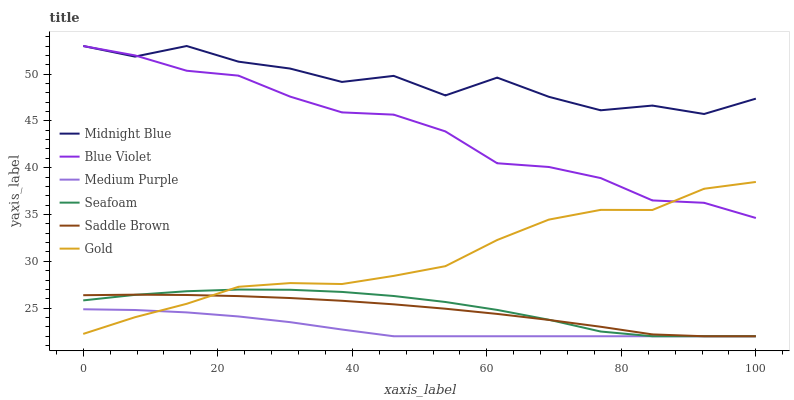Does Medium Purple have the minimum area under the curve?
Answer yes or no. Yes. Does Midnight Blue have the maximum area under the curve?
Answer yes or no. Yes. Does Gold have the minimum area under the curve?
Answer yes or no. No. Does Gold have the maximum area under the curve?
Answer yes or no. No. Is Medium Purple the smoothest?
Answer yes or no. Yes. Is Midnight Blue the roughest?
Answer yes or no. Yes. Is Gold the smoothest?
Answer yes or no. No. Is Gold the roughest?
Answer yes or no. No. Does Seafoam have the lowest value?
Answer yes or no. Yes. Does Gold have the lowest value?
Answer yes or no. No. Does Blue Violet have the highest value?
Answer yes or no. Yes. Does Gold have the highest value?
Answer yes or no. No. Is Seafoam less than Midnight Blue?
Answer yes or no. Yes. Is Midnight Blue greater than Seafoam?
Answer yes or no. Yes. Does Medium Purple intersect Saddle Brown?
Answer yes or no. Yes. Is Medium Purple less than Saddle Brown?
Answer yes or no. No. Is Medium Purple greater than Saddle Brown?
Answer yes or no. No. Does Seafoam intersect Midnight Blue?
Answer yes or no. No. 